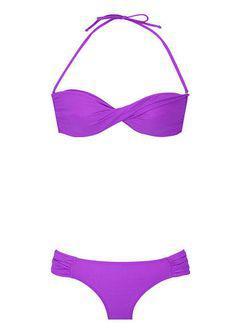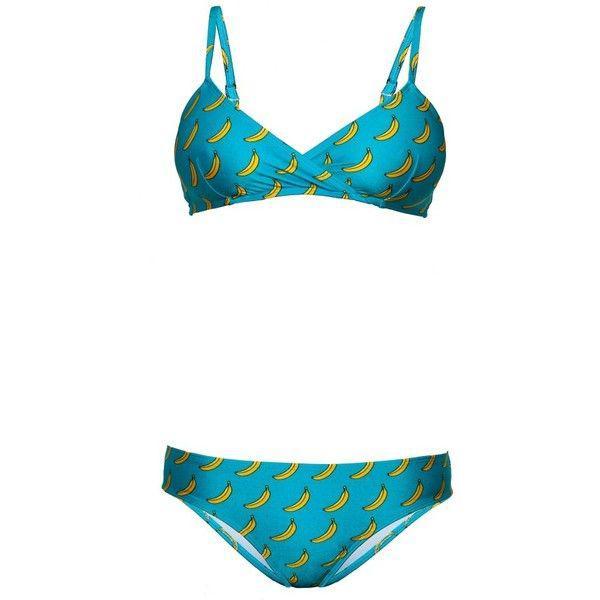The first image is the image on the left, the second image is the image on the right. Evaluate the accuracy of this statement regarding the images: "All bikini tops are over-the-shoulder style, rather than tied around the neck.". Is it true? Answer yes or no. No. 